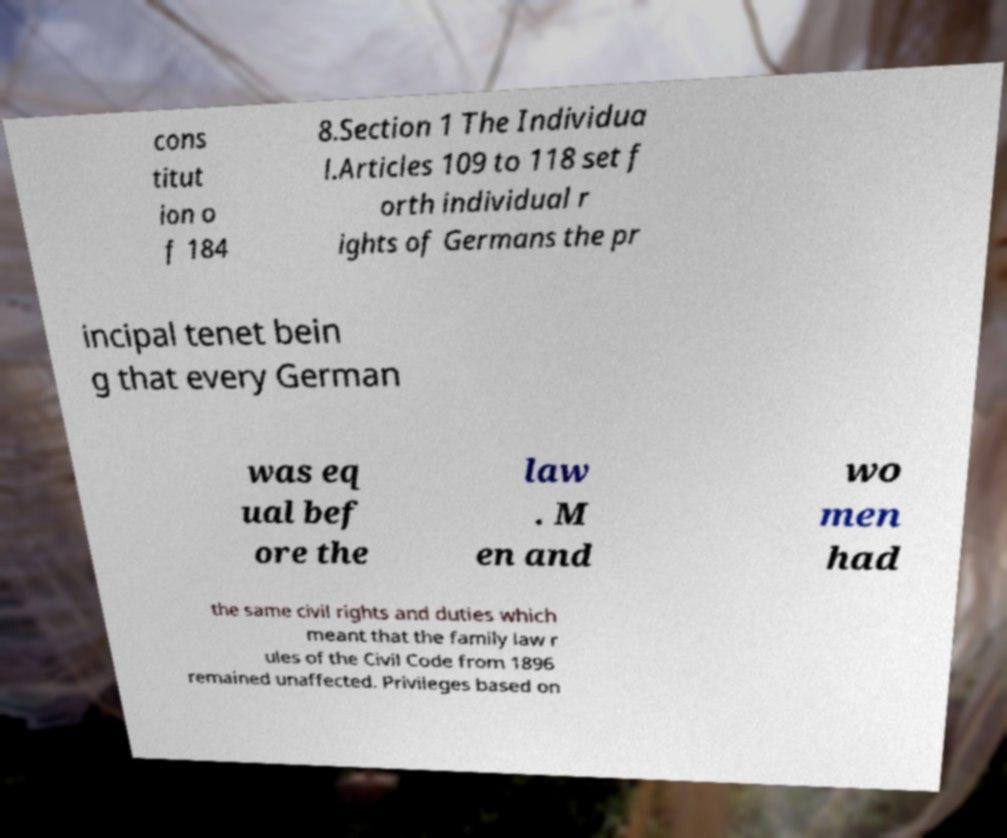Can you read and provide the text displayed in the image?This photo seems to have some interesting text. Can you extract and type it out for me? cons titut ion o f 184 8.Section 1 The Individua l.Articles 109 to 118 set f orth individual r ights of Germans the pr incipal tenet bein g that every German was eq ual bef ore the law . M en and wo men had the same civil rights and duties which meant that the family law r ules of the Civil Code from 1896 remained unaffected. Privileges based on 